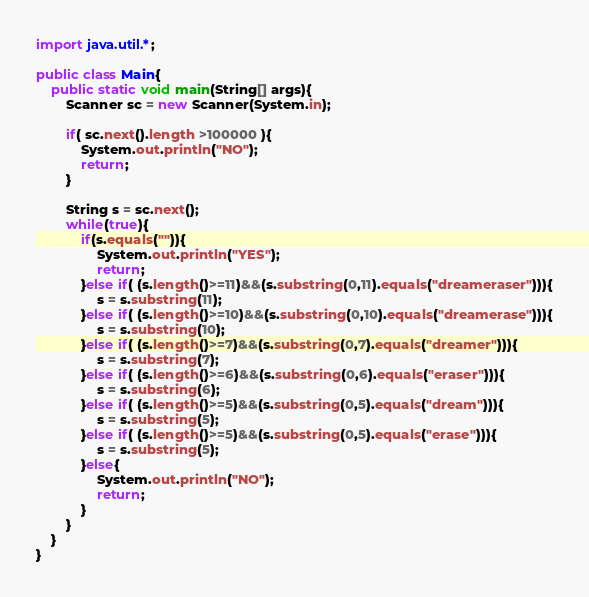Convert code to text. <code><loc_0><loc_0><loc_500><loc_500><_Java_>import java.util.*;

public class Main{
	public static void main(String[] args){
		Scanner sc = new Scanner(System.in);

		if( sc.next().length >100000 ){
			System.out.println("NO");
			return;
		}

		String s = sc.next();
		while(true){
			if(s.equals("")){
				System.out.println("YES");
				return;
			}else if( (s.length()>=11)&&(s.substring(0,11).equals("dreameraser"))){
				s = s.substring(11);
			}else if( (s.length()>=10)&&(s.substring(0,10).equals("dreamerase"))){
				s = s.substring(10);
			}else if( (s.length()>=7)&&(s.substring(0,7).equals("dreamer"))){
				s = s.substring(7);
			}else if( (s.length()>=6)&&(s.substring(0,6).equals("eraser"))){
				s = s.substring(6);
			}else if( (s.length()>=5)&&(s.substring(0,5).equals("dream"))){
				s = s.substring(5);
			}else if( (s.length()>=5)&&(s.substring(0,5).equals("erase"))){
				s = s.substring(5);
			}else{
				System.out.println("NO");
				return;
			}
		}
	}
}</code> 